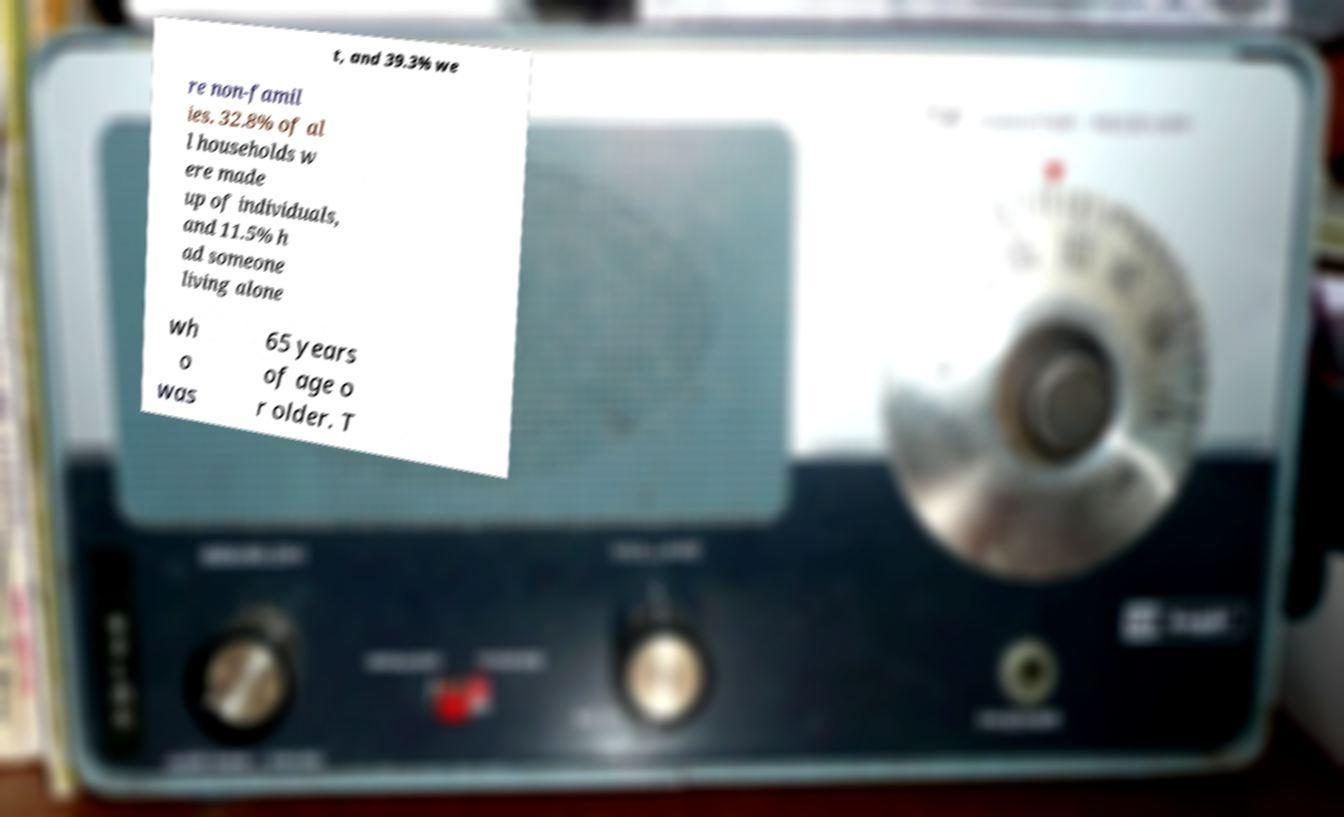Can you read and provide the text displayed in the image?This photo seems to have some interesting text. Can you extract and type it out for me? t, and 39.3% we re non-famil ies. 32.8% of al l households w ere made up of individuals, and 11.5% h ad someone living alone wh o was 65 years of age o r older. T 